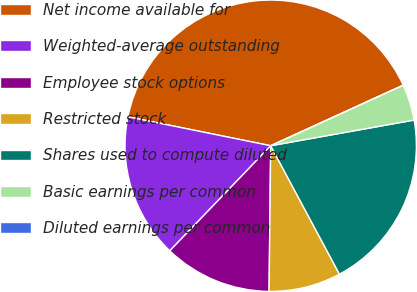Convert chart. <chart><loc_0><loc_0><loc_500><loc_500><pie_chart><fcel>Net income available for<fcel>Weighted-average outstanding<fcel>Employee stock options<fcel>Restricted stock<fcel>Shares used to compute diluted<fcel>Basic earnings per common<fcel>Diluted earnings per common<nl><fcel>40.0%<fcel>16.0%<fcel>12.0%<fcel>8.0%<fcel>20.0%<fcel>4.0%<fcel>0.0%<nl></chart> 